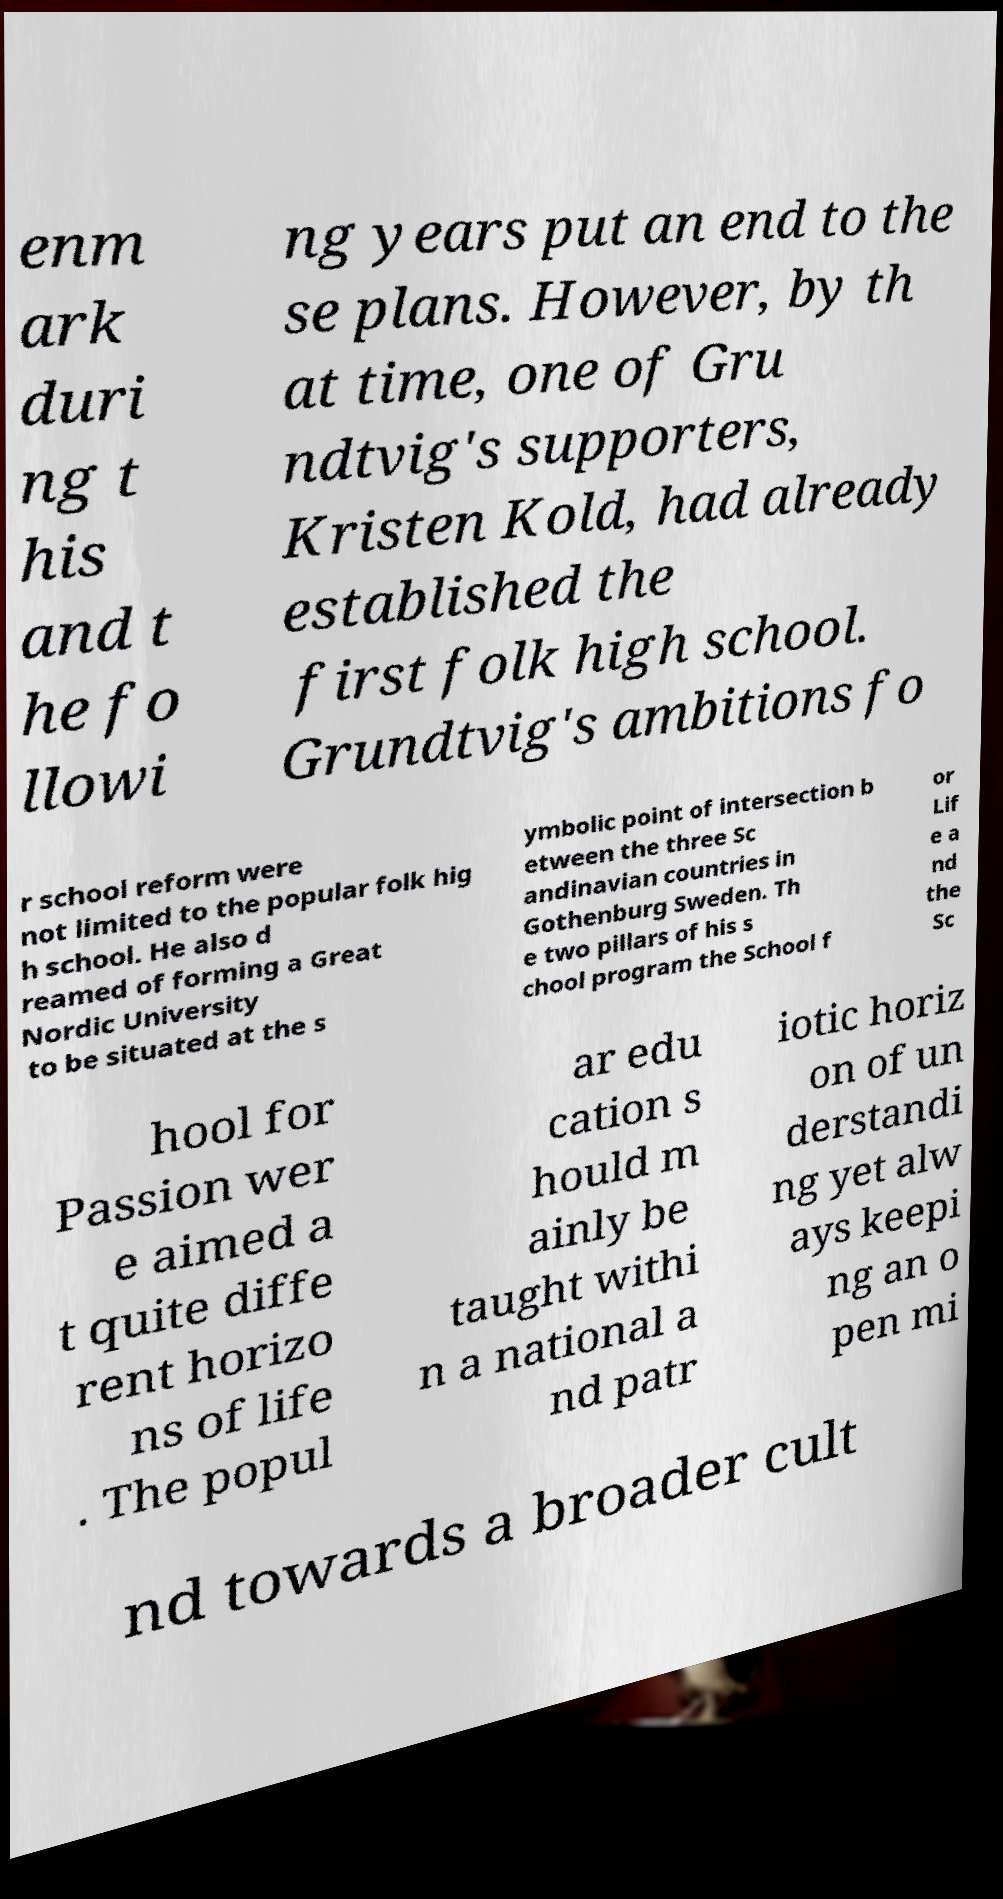Please identify and transcribe the text found in this image. enm ark duri ng t his and t he fo llowi ng years put an end to the se plans. However, by th at time, one of Gru ndtvig's supporters, Kristen Kold, had already established the first folk high school. Grundtvig's ambitions fo r school reform were not limited to the popular folk hig h school. He also d reamed of forming a Great Nordic University to be situated at the s ymbolic point of intersection b etween the three Sc andinavian countries in Gothenburg Sweden. Th e two pillars of his s chool program the School f or Lif e a nd the Sc hool for Passion wer e aimed a t quite diffe rent horizo ns of life . The popul ar edu cation s hould m ainly be taught withi n a national a nd patr iotic horiz on of un derstandi ng yet alw ays keepi ng an o pen mi nd towards a broader cult 